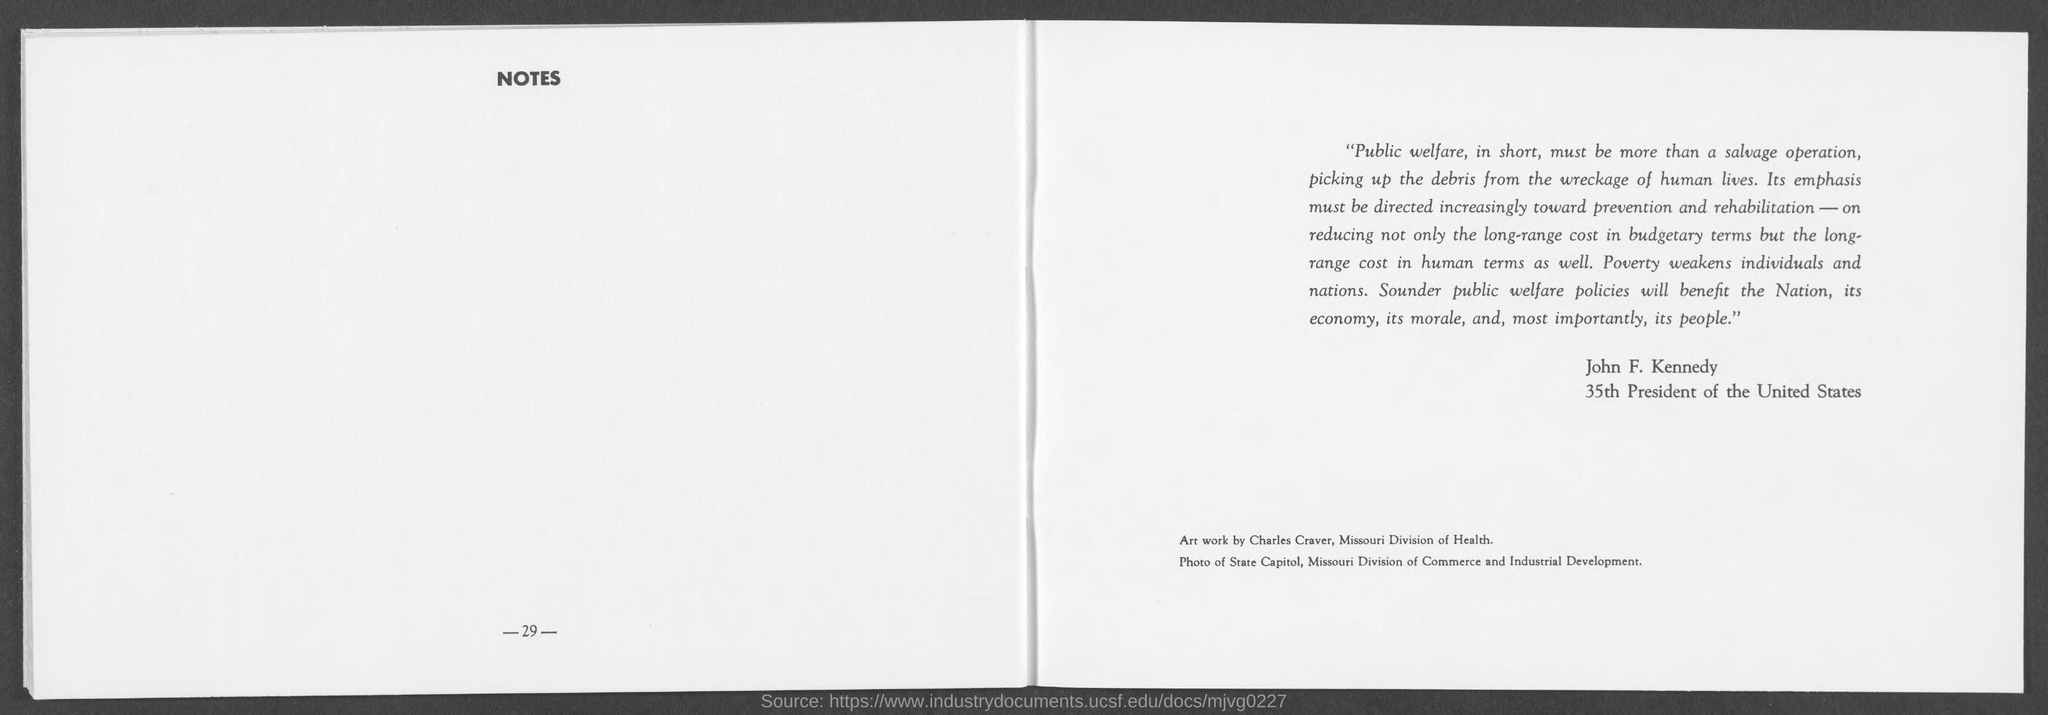What must be more than a salvage operation, picking up the debris from the wreckage of human lives?
Provide a short and direct response. Public Welfare. Who is the 35th President of the United States?
Keep it short and to the point. John F. Kennedy. 